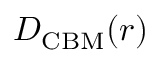Convert formula to latex. <formula><loc_0><loc_0><loc_500><loc_500>D _ { C B M } ( r )</formula> 